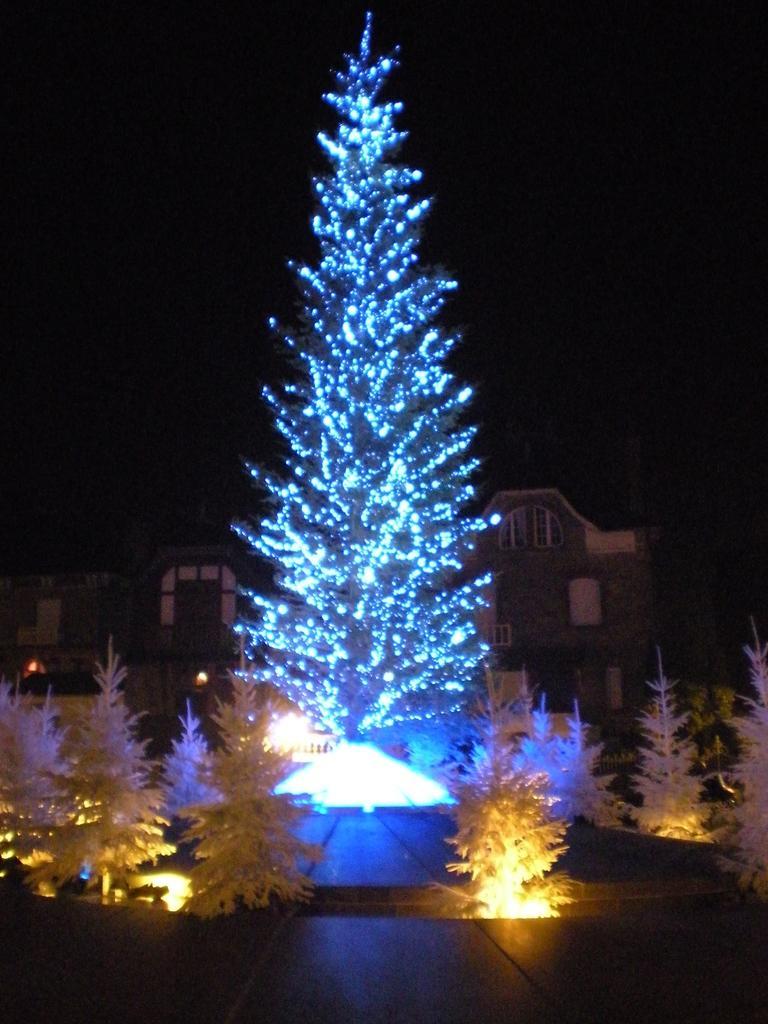Please provide a concise description of this image. In this picture there are decorative plants in the center of the image and there are houses in the background area of the image. 